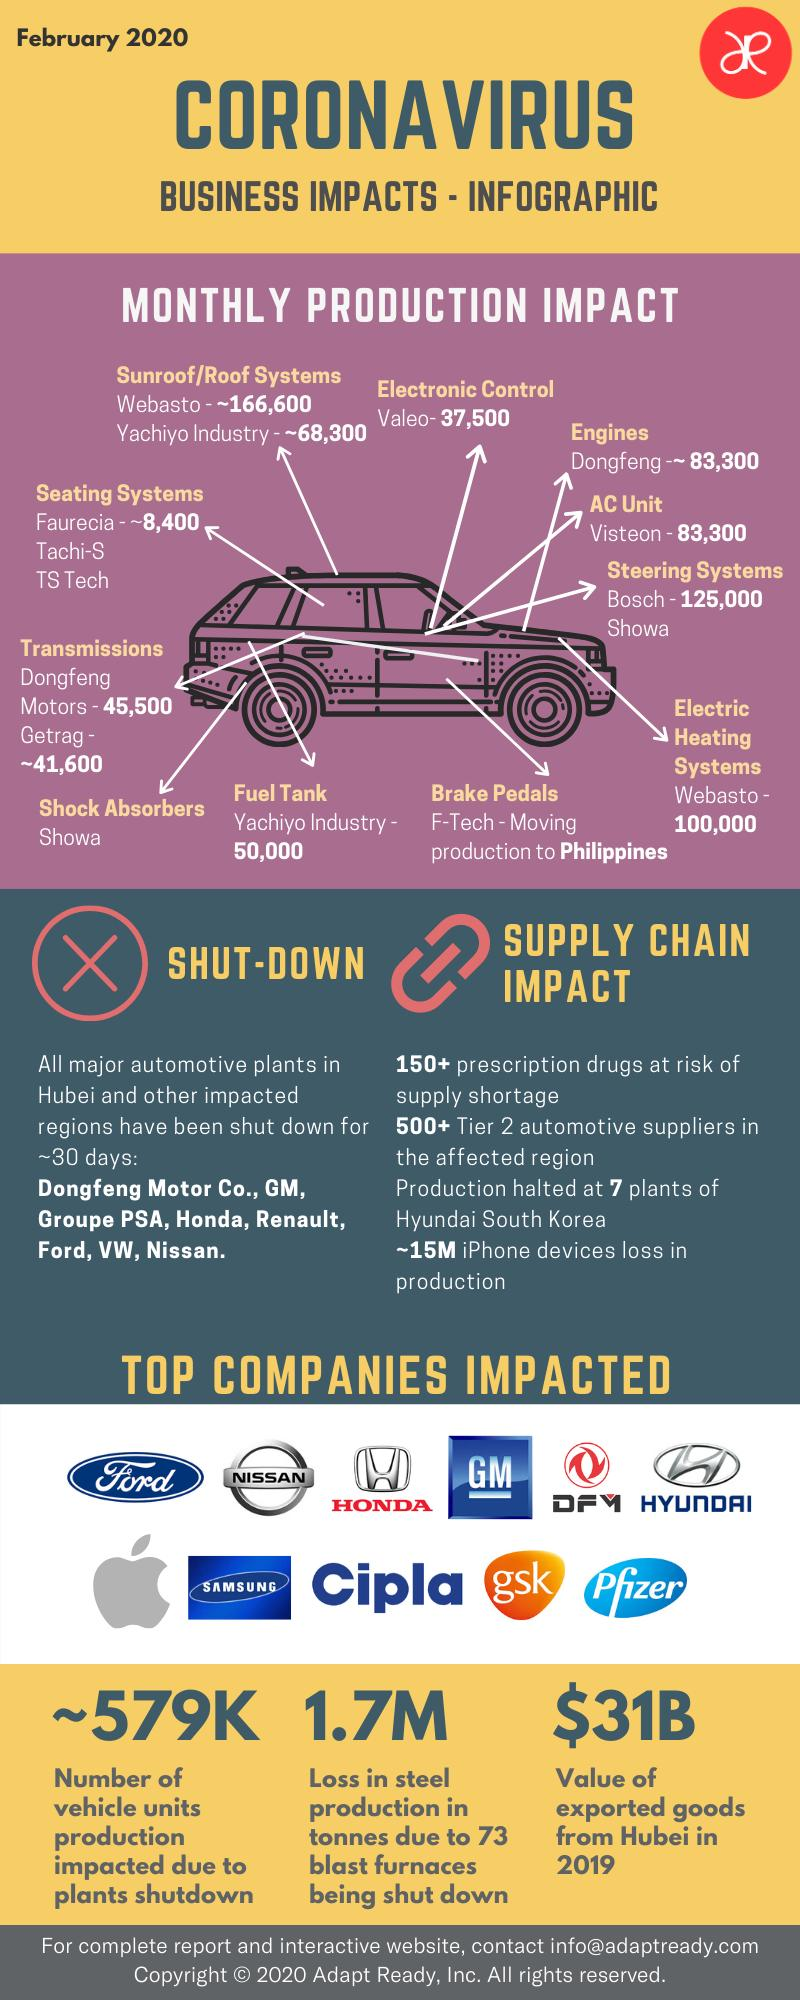Identify some key points in this picture. The value of exported goods from Hubei in 2019 was approximately $31 billion. The production of vehicle units was impacted by approximately 579,000 due to the shutdown of the plants in February 2020. 